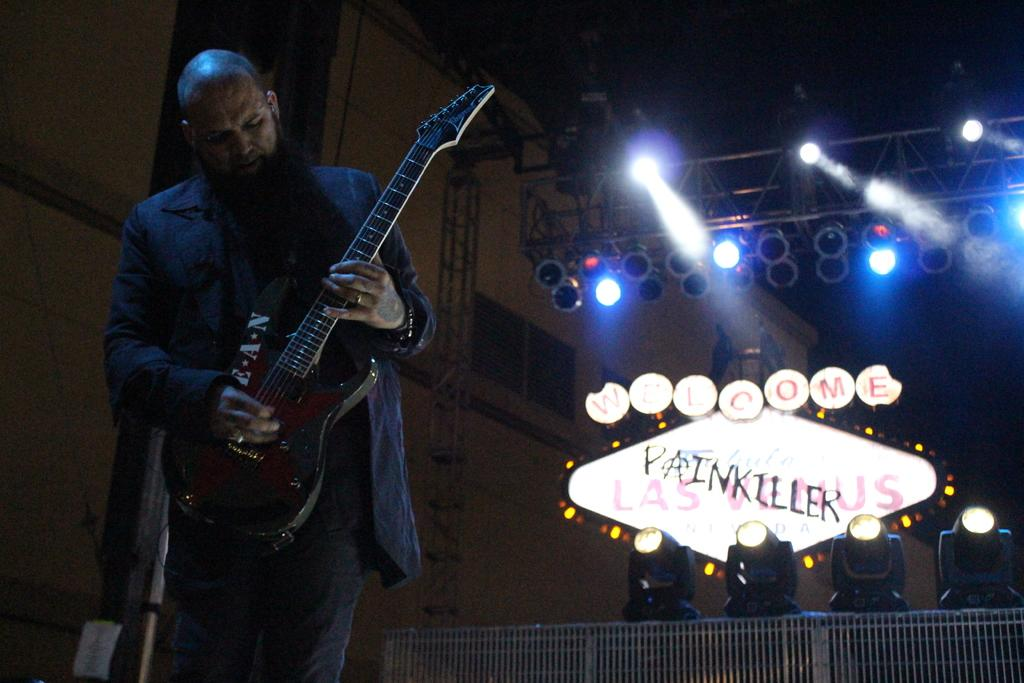What is the person in the image doing? The person is playing the guitar. What object is the person holding while playing the guitar? The person is holding a guitar. What can be seen in the background of the image? There are lights and a poster visible in the background of the image. How many oranges are on the person's head in the image? There are no oranges present in the image. What type of cow can be seen in the background of the image? There is no cow present in the image. 